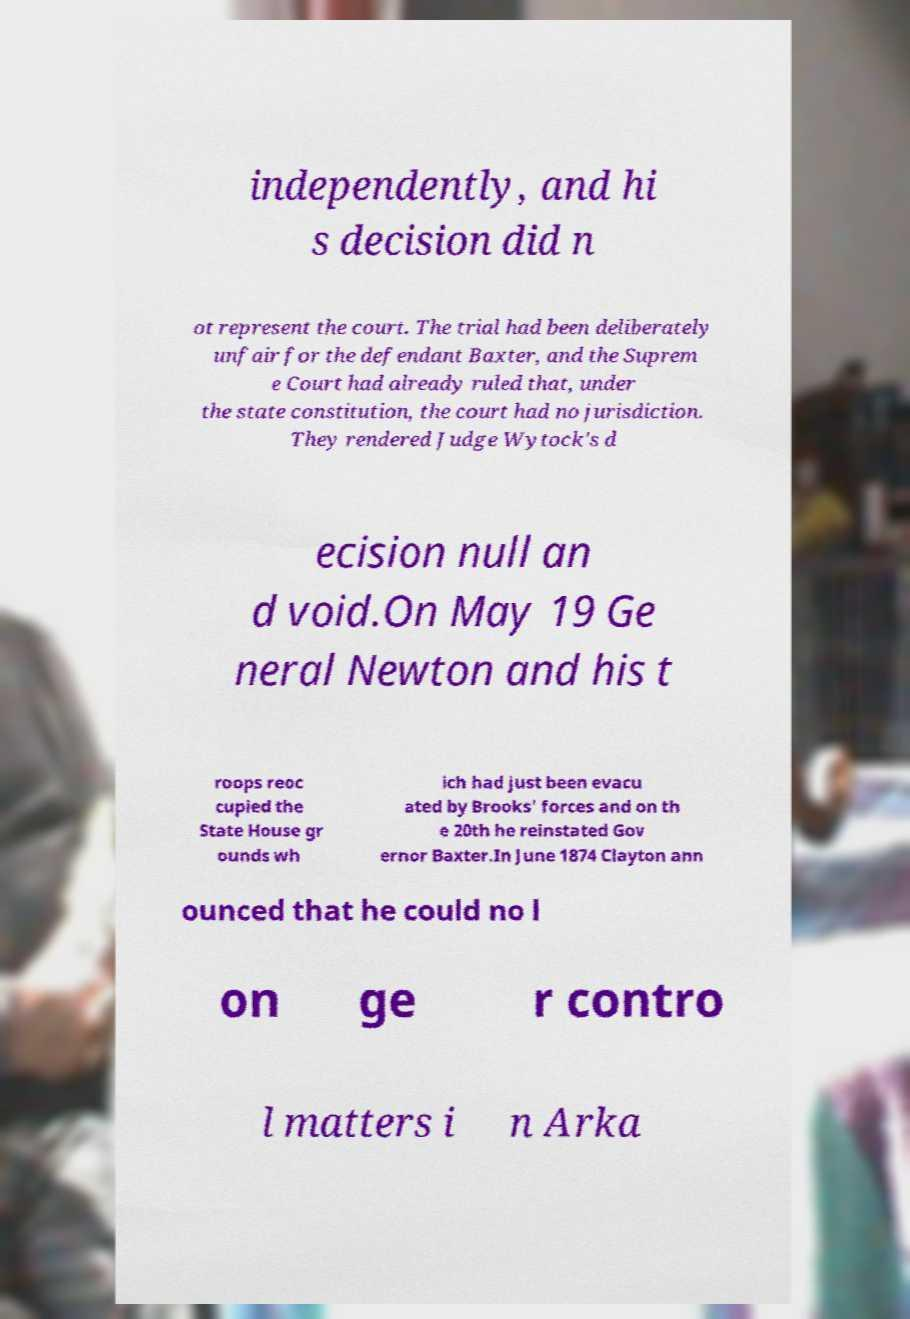There's text embedded in this image that I need extracted. Can you transcribe it verbatim? independently, and hi s decision did n ot represent the court. The trial had been deliberately unfair for the defendant Baxter, and the Suprem e Court had already ruled that, under the state constitution, the court had no jurisdiction. They rendered Judge Wytock's d ecision null an d void.On May 19 Ge neral Newton and his t roops reoc cupied the State House gr ounds wh ich had just been evacu ated by Brooks' forces and on th e 20th he reinstated Gov ernor Baxter.In June 1874 Clayton ann ounced that he could no l on ge r contro l matters i n Arka 